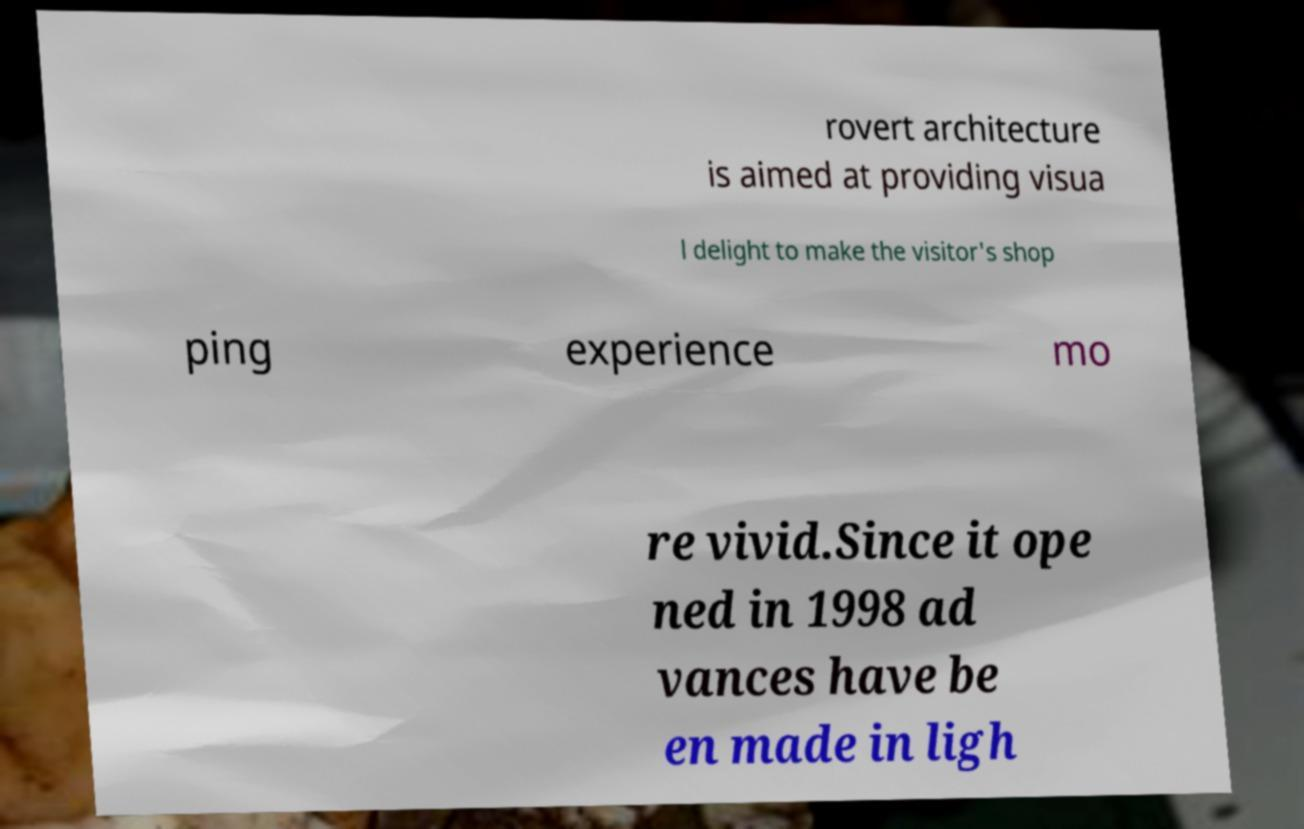Could you extract and type out the text from this image? rovert architecture is aimed at providing visua l delight to make the visitor's shop ping experience mo re vivid.Since it ope ned in 1998 ad vances have be en made in ligh 